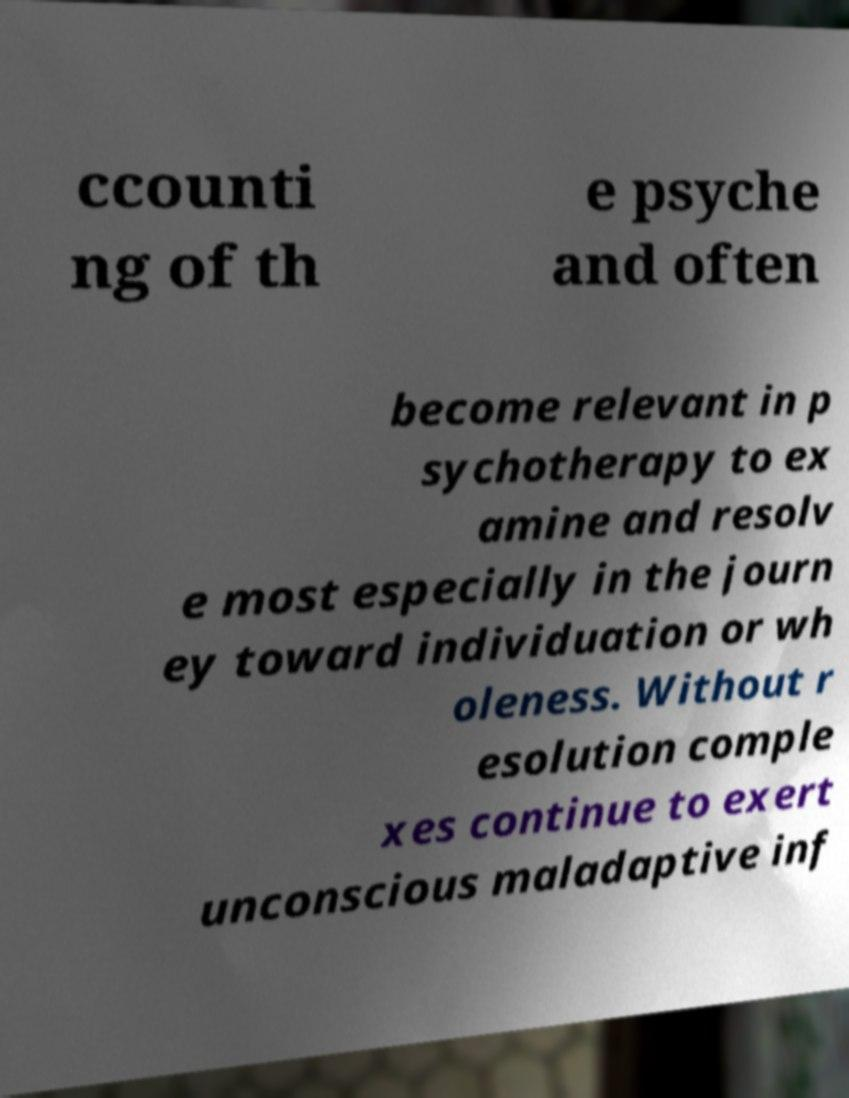I need the written content from this picture converted into text. Can you do that? ccounti ng of th e psyche and often become relevant in p sychotherapy to ex amine and resolv e most especially in the journ ey toward individuation or wh oleness. Without r esolution comple xes continue to exert unconscious maladaptive inf 